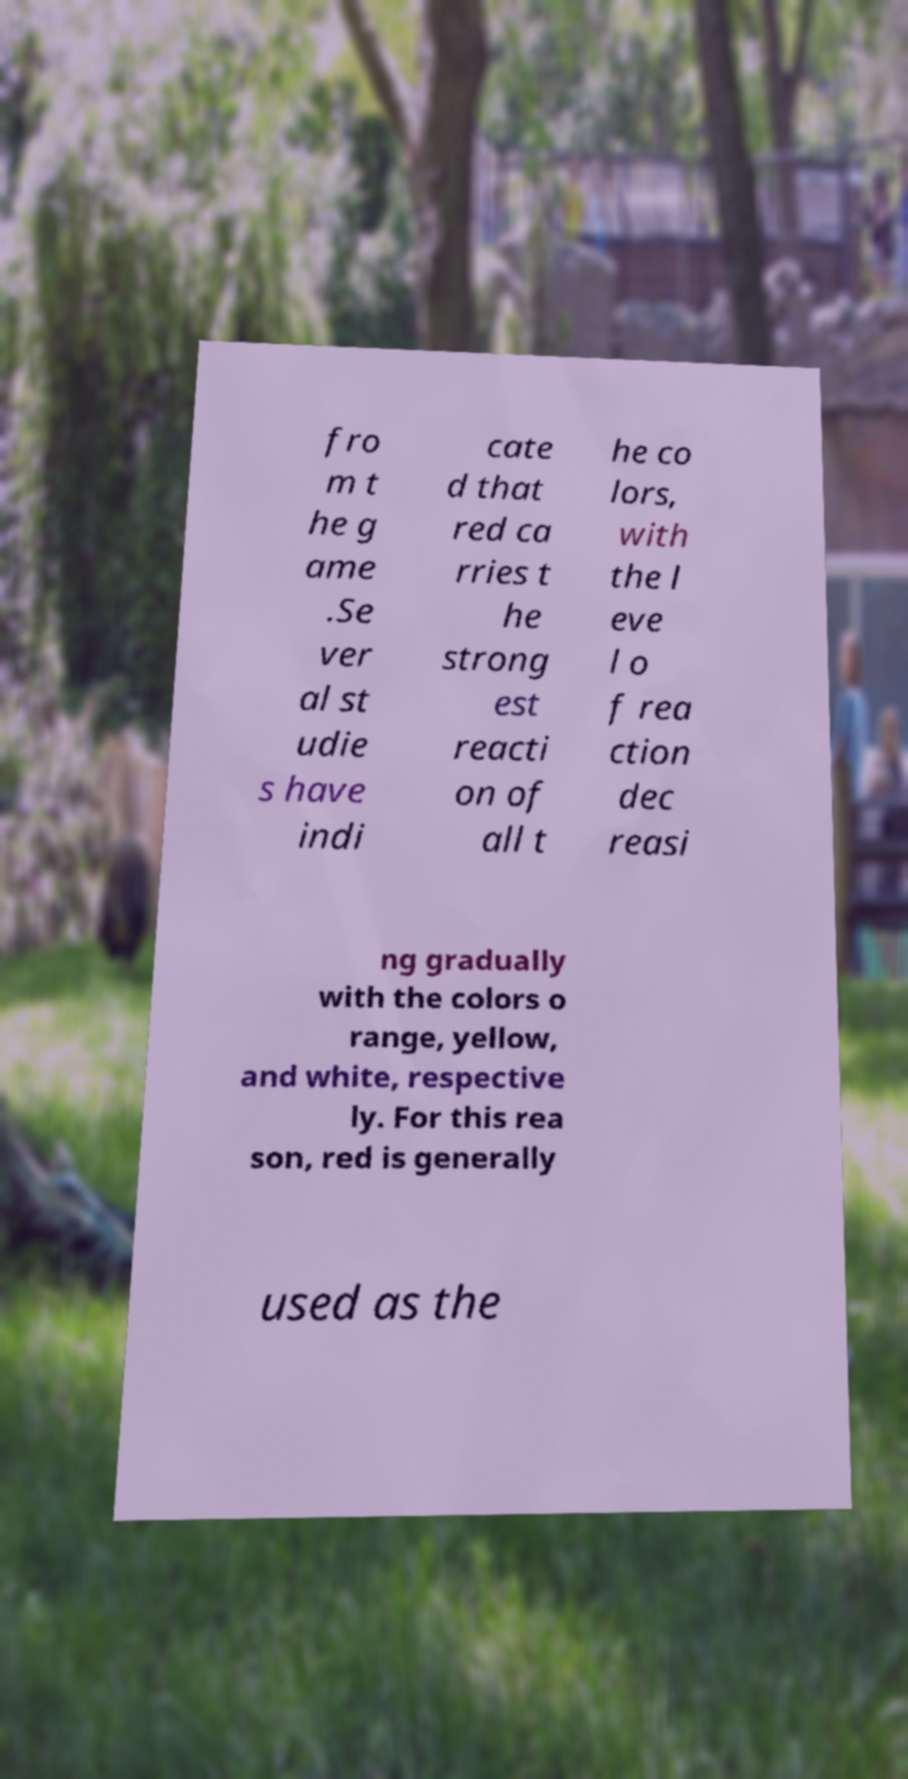There's text embedded in this image that I need extracted. Can you transcribe it verbatim? fro m t he g ame .Se ver al st udie s have indi cate d that red ca rries t he strong est reacti on of all t he co lors, with the l eve l o f rea ction dec reasi ng gradually with the colors o range, yellow, and white, respective ly. For this rea son, red is generally used as the 